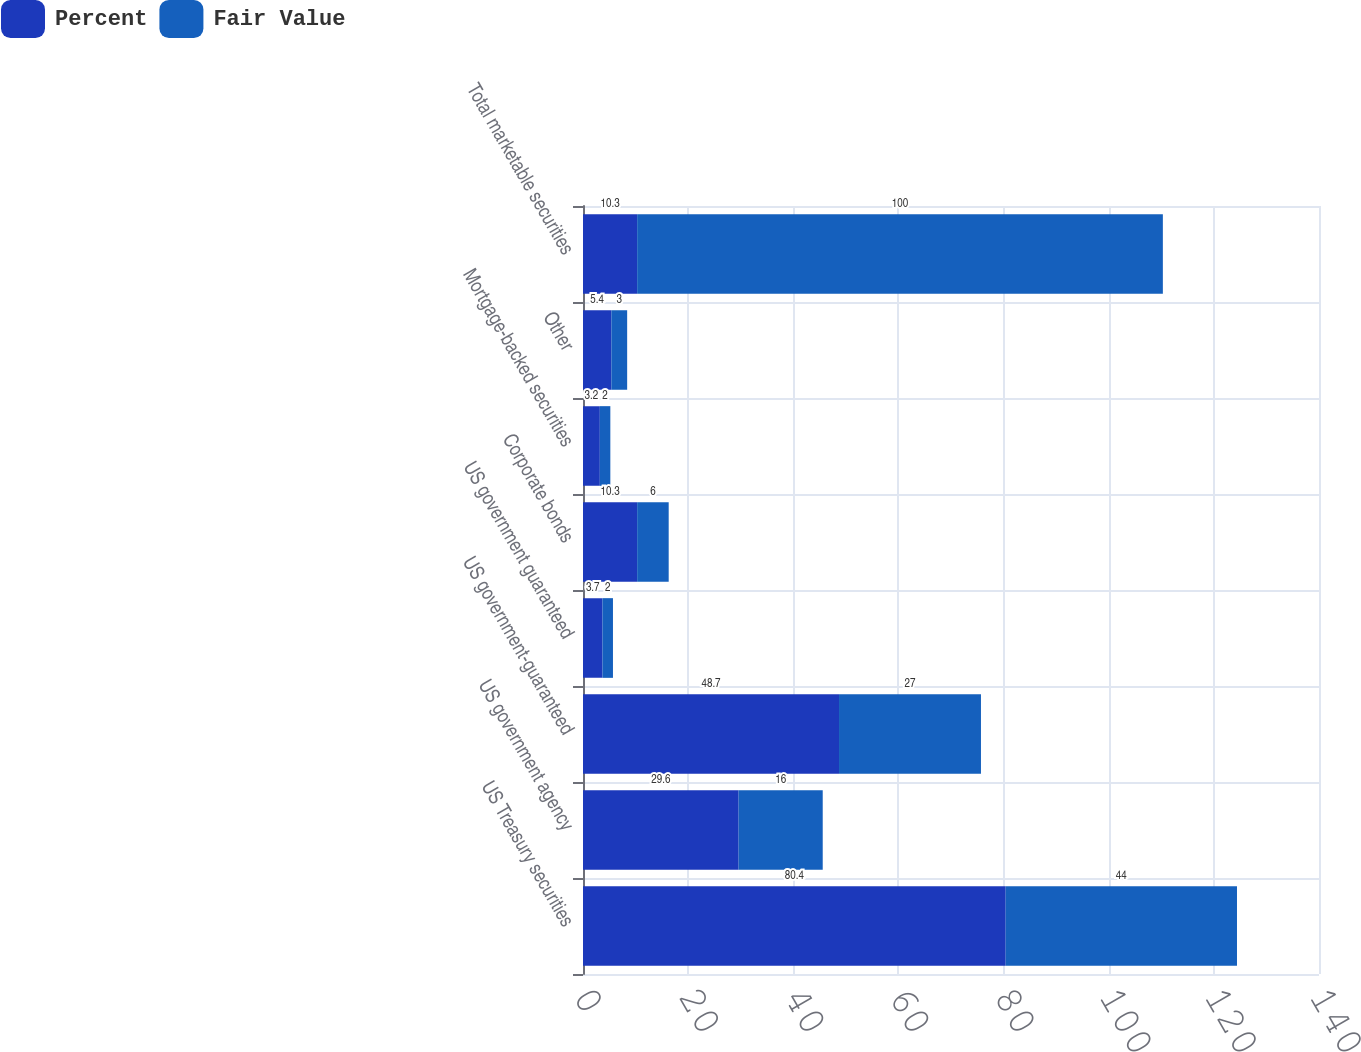<chart> <loc_0><loc_0><loc_500><loc_500><stacked_bar_chart><ecel><fcel>US Treasury securities<fcel>US government agency<fcel>US government-guaranteed<fcel>US government guaranteed<fcel>Corporate bonds<fcel>Mortgage-backed securities<fcel>Other<fcel>Total marketable securities<nl><fcel>Percent<fcel>80.4<fcel>29.6<fcel>48.7<fcel>3.7<fcel>10.3<fcel>3.2<fcel>5.4<fcel>10.3<nl><fcel>Fair Value<fcel>44<fcel>16<fcel>27<fcel>2<fcel>6<fcel>2<fcel>3<fcel>100<nl></chart> 